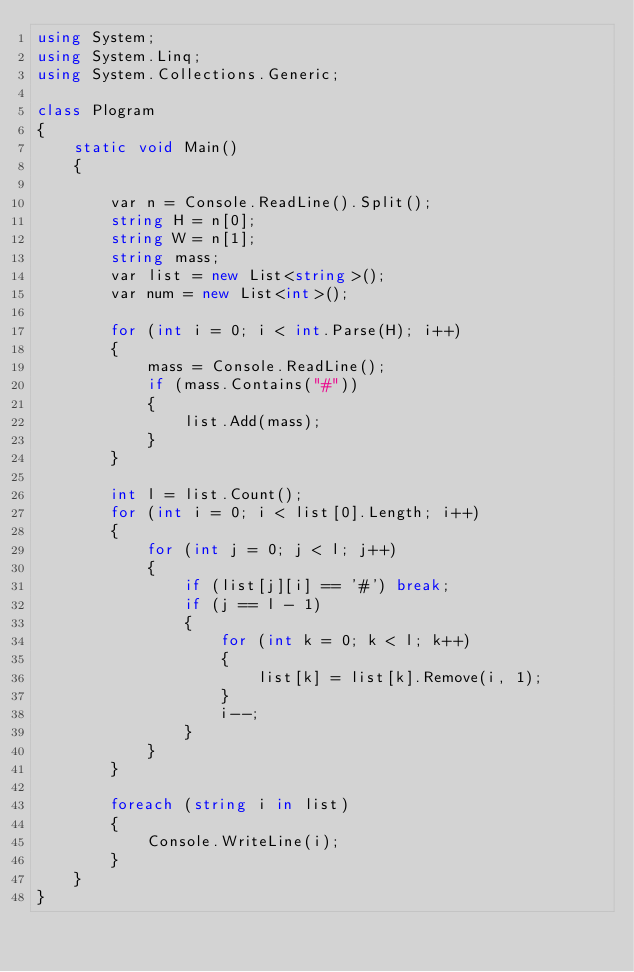Convert code to text. <code><loc_0><loc_0><loc_500><loc_500><_C#_>using System;
using System.Linq;
using System.Collections.Generic;

class Plogram
{
    static void Main()
    {

        var n = Console.ReadLine().Split();
        string H = n[0];
        string W = n[1];
        string mass;
        var list = new List<string>();
        var num = new List<int>();

        for (int i = 0; i < int.Parse(H); i++)
        {
            mass = Console.ReadLine();
            if (mass.Contains("#"))
            {
                list.Add(mass);
            }
        }

        int l = list.Count();
        for (int i = 0; i < list[0].Length; i++)
        {
            for (int j = 0; j < l; j++)
            {
                if (list[j][i] == '#') break;
                if (j == l - 1)
                {
                    for (int k = 0; k < l; k++)
                    {
                        list[k] = list[k].Remove(i, 1);
                    }
                    i--;
                }
            }
        }

        foreach (string i in list)
        {
            Console.WriteLine(i);
        }
    }
}</code> 